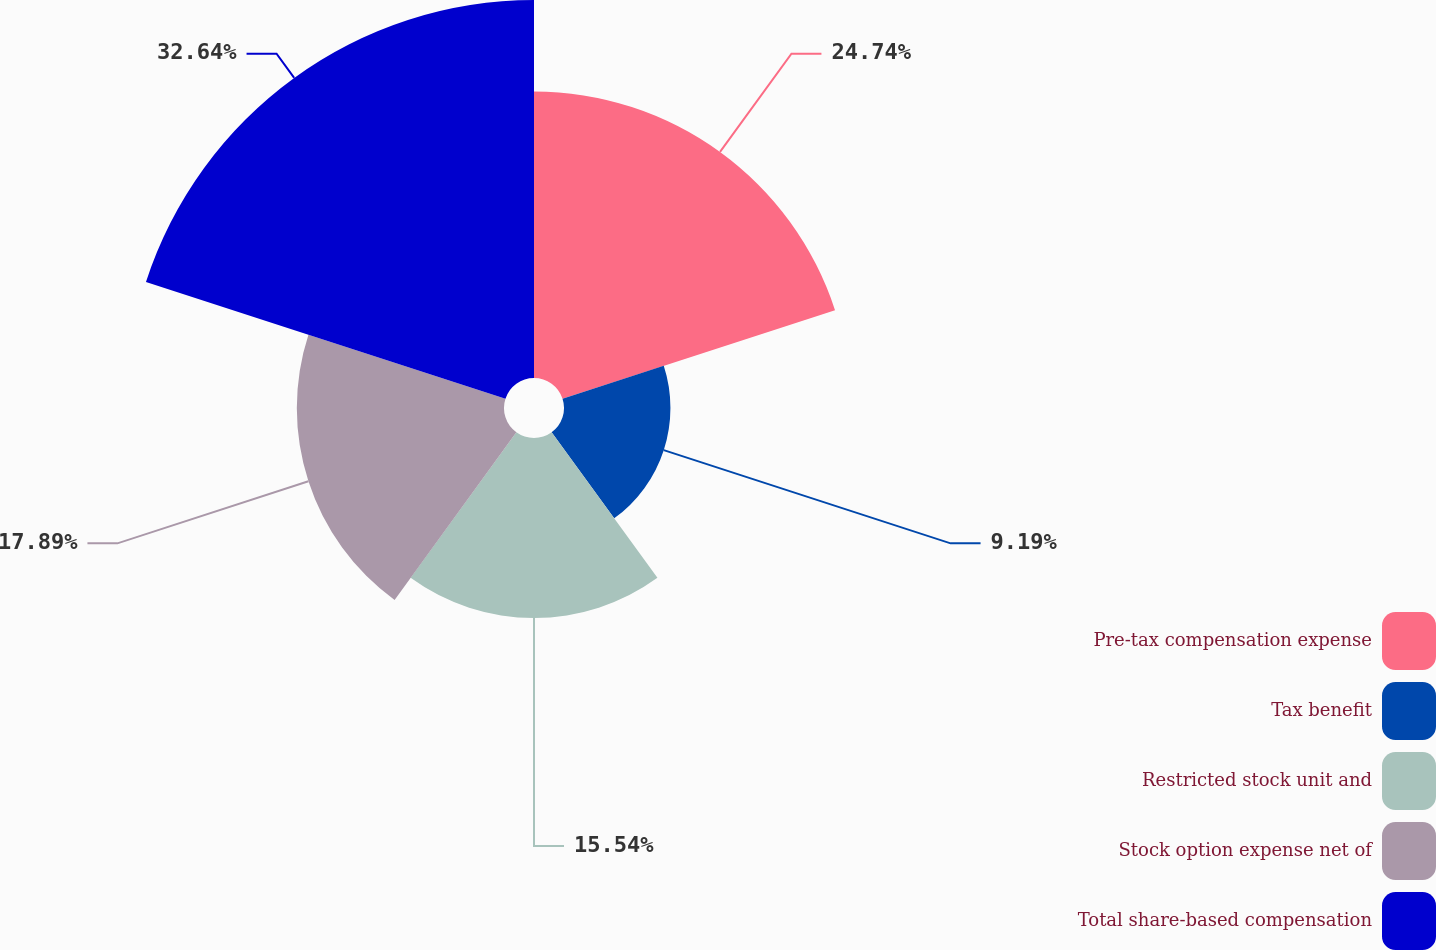Convert chart to OTSL. <chart><loc_0><loc_0><loc_500><loc_500><pie_chart><fcel>Pre-tax compensation expense<fcel>Tax benefit<fcel>Restricted stock unit and<fcel>Stock option expense net of<fcel>Total share-based compensation<nl><fcel>24.74%<fcel>9.19%<fcel>15.54%<fcel>17.89%<fcel>32.64%<nl></chart> 